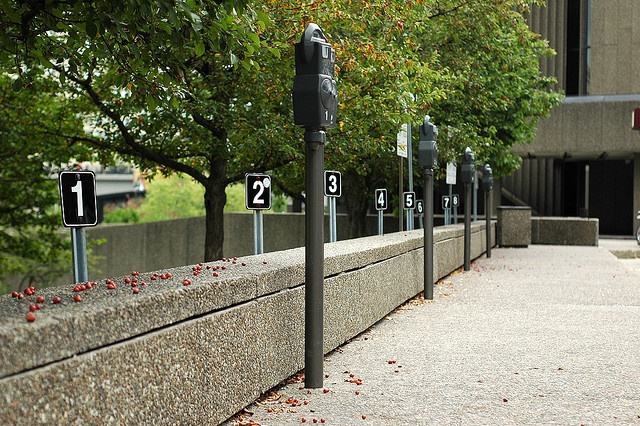Describe the objects in this image and their specific colors. I can see parking meter in black, gray, darkgray, and lightgray tones, parking meter in black, gray, and darkgray tones, parking meter in black, gray, and darkgreen tones, and parking meter in black, gray, darkgray, and darkgreen tones in this image. 